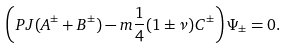Convert formula to latex. <formula><loc_0><loc_0><loc_500><loc_500>\left ( P J ( A ^ { \pm } + B ^ { \pm } ) - m \frac { 1 } { 4 } ( 1 \pm \nu ) C ^ { \pm } \right ) \Psi _ { \pm } = 0 .</formula> 